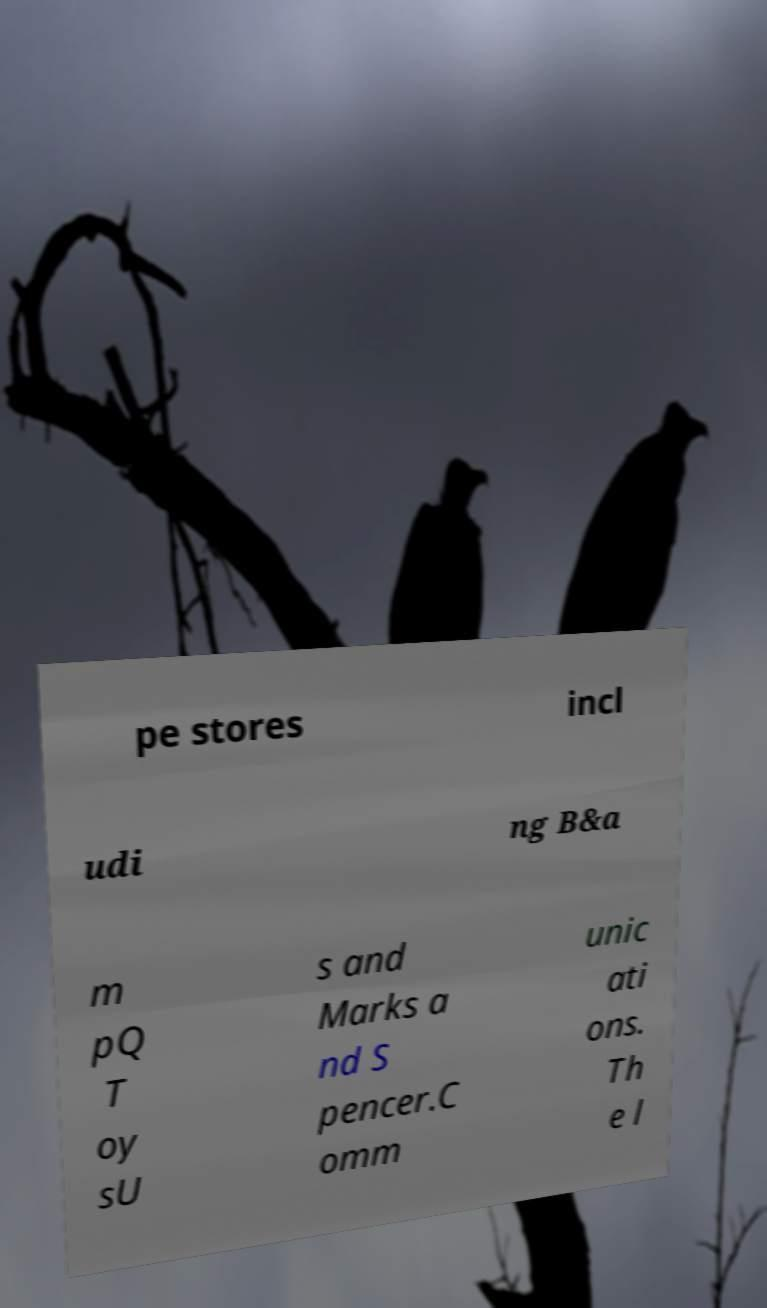Can you accurately transcribe the text from the provided image for me? pe stores incl udi ng B&a m pQ T oy sU s and Marks a nd S pencer.C omm unic ati ons. Th e l 